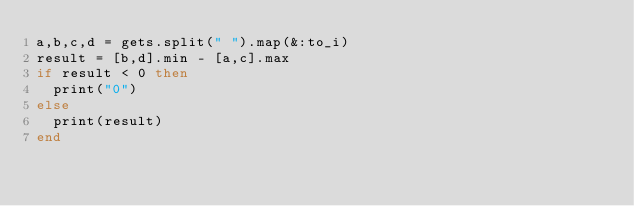Convert code to text. <code><loc_0><loc_0><loc_500><loc_500><_Ruby_>a,b,c,d = gets.split(" ").map(&:to_i)
result = [b,d].min - [a,c].max
if result < 0 then
  print("0")
else
  print(result)
end
</code> 